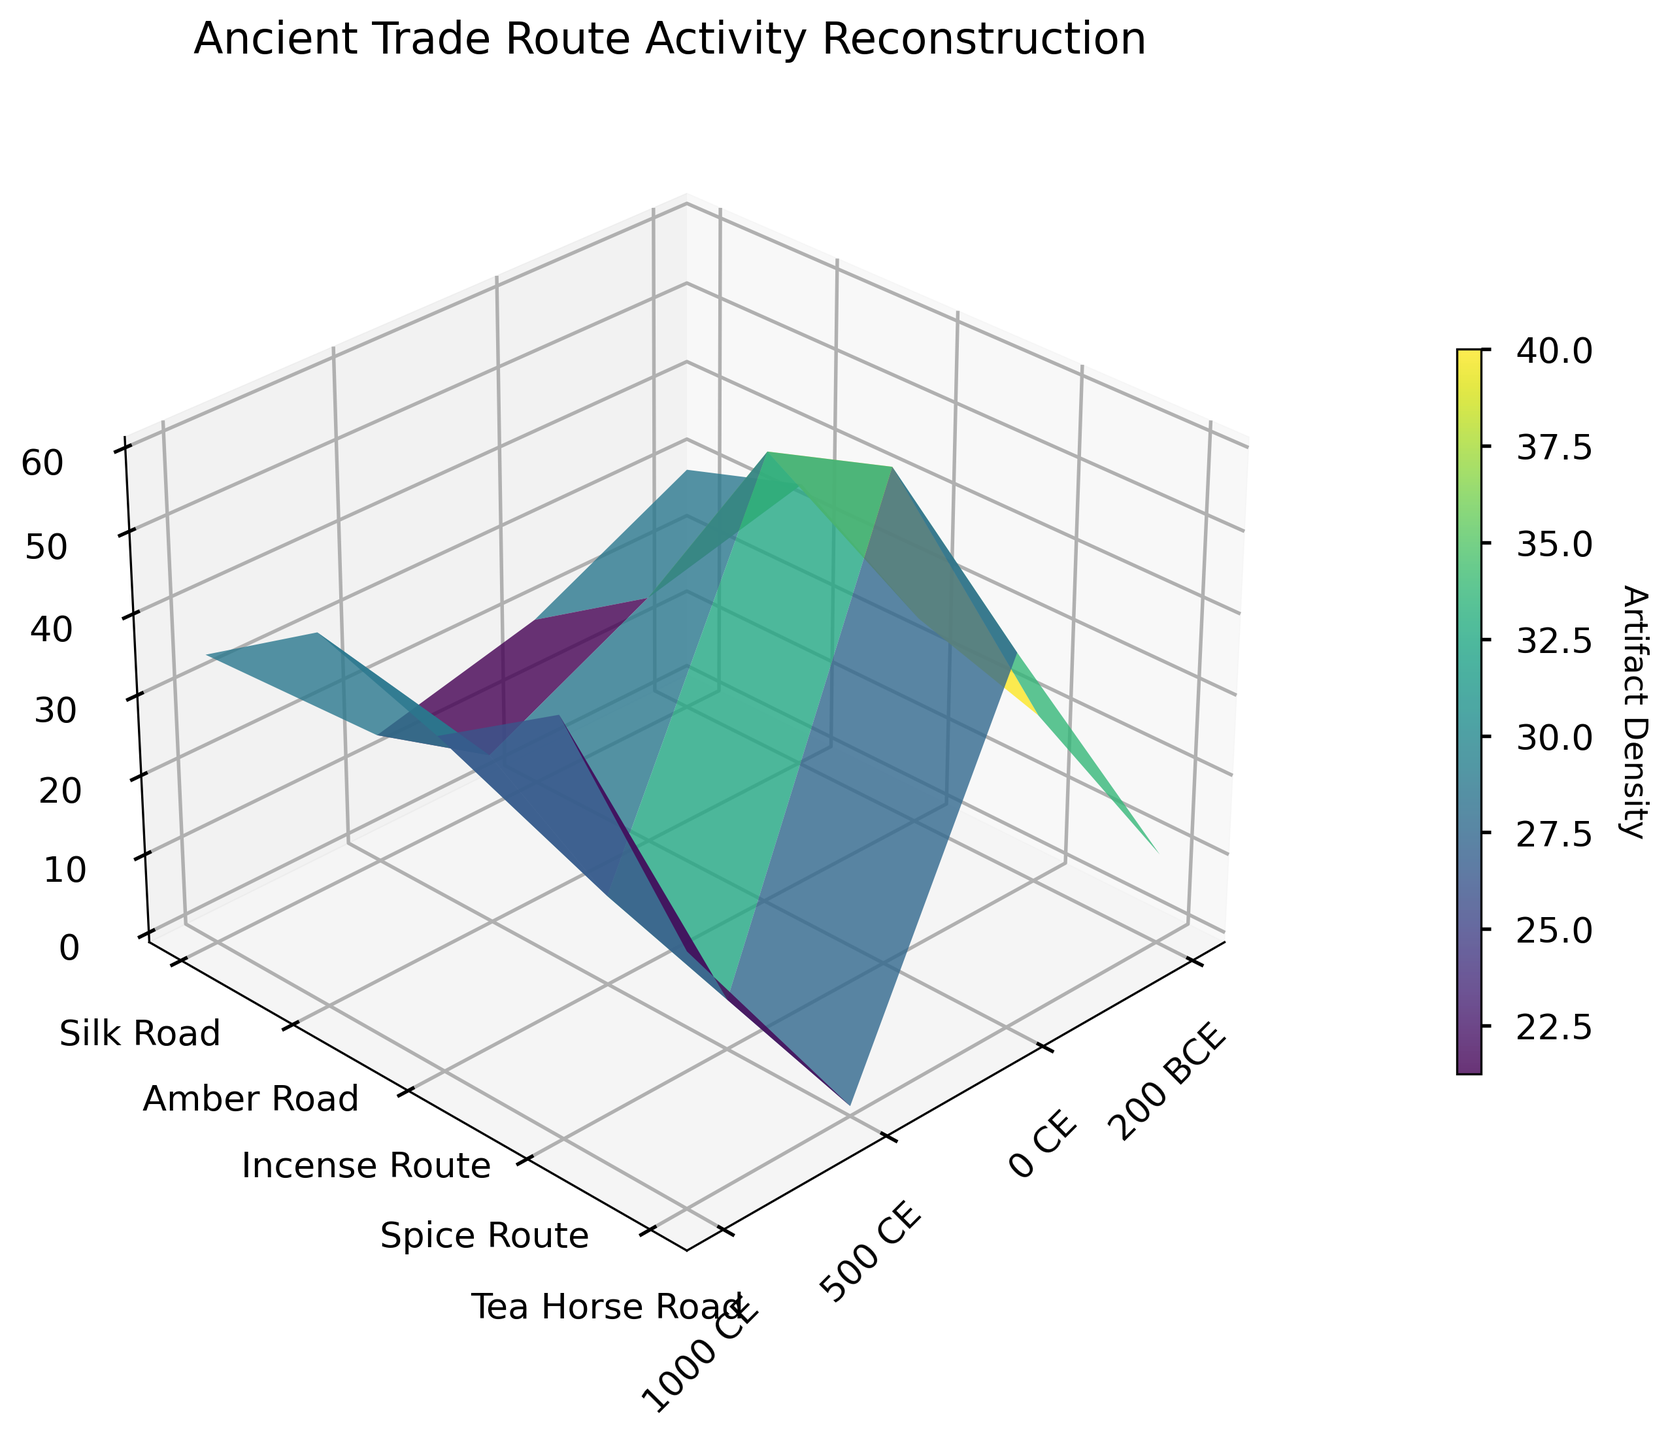What's the title of the figure? The title of the figure is displayed at the top center of the plot and reads "Ancient Trade Route Activity Reconstruction".
Answer: Ancient Trade Route Activity Reconstruction What are the axes labeled? The x-axis represents the Time Periods, the y-axis represents the Trade Routes, and the z-axis is labeled 'Artifact Density'.
Answer: Time Periods, Trade Routes, Artifact Density Which trade route had the highest artifact density in 1000 CE? By examining the surface plot, you can see that the Spice Route had the highest peak in the 1000 CE column, indicating the highest artifact density at that time.
Answer: Spice Route How does the artifact density change for the Silk Road from 200 BCE to 1000 CE? For the Silk Road, observe the z-values along the corresponding x-coordinates: the data points go from 10 in 200 BCE, then 25 in 0 CE, reaching 40 in 500 CE, and finally 55 in 1000 CE. The artifact density consistently increases over time.
Answer: Consistent increase Compare the artifact densities of the Amber Road and Incense Route in 500 CE. Which is higher? Look at the 500 CE column and compare the heights of the surfaces corresponding to the Amber Road and Incense Route. The Incense Route is higher at 500 CE, with a value of 45 compared to the Amber Road's 35.
Answer: Incense Route What is the average artifact density on the Tea Horse Road across all time periods? Sum the artifact densities for the Tea Horse Road (0 + 10 + 30 + 45) and divide by the number of periods (4). The calculation is (0 + 10 + 30 + 45) = 85, and 85 / 4 = 21.25.
Answer: 21.25 Identify which trade route had the lowest artifact density in 200 BCE. Observe the 200 BCE column and identify the lowest surface height, which corresponds to the Tea Horse Road with an artifact density of 0.
Answer: Tea Horse Road Which time period shows the highest variation in artifact densities among all trade routes? Examine the height variations across trade routes for each time period. The 1000 CE column shows the greatest range, with artifact densities varying from 20 (Amber Road) to 60 (Spice Route).
Answer: 1000 CE On the 3D surface plot, which trade route shows a general decreasing trend of artifact density from 0 CE to 1000 CE? Examine the trade routes and their artifact densities at 0 CE and 1000 CE. The Amber Road shows this pattern, decreasing from 30 in 0 CE to 20 in 1000 CE.
Answer: Amber Road 